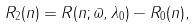<formula> <loc_0><loc_0><loc_500><loc_500>R _ { 2 } ( n ) = R ( n ; \varpi , \lambda _ { 0 } ) - R _ { 0 } ( n ) ,</formula> 